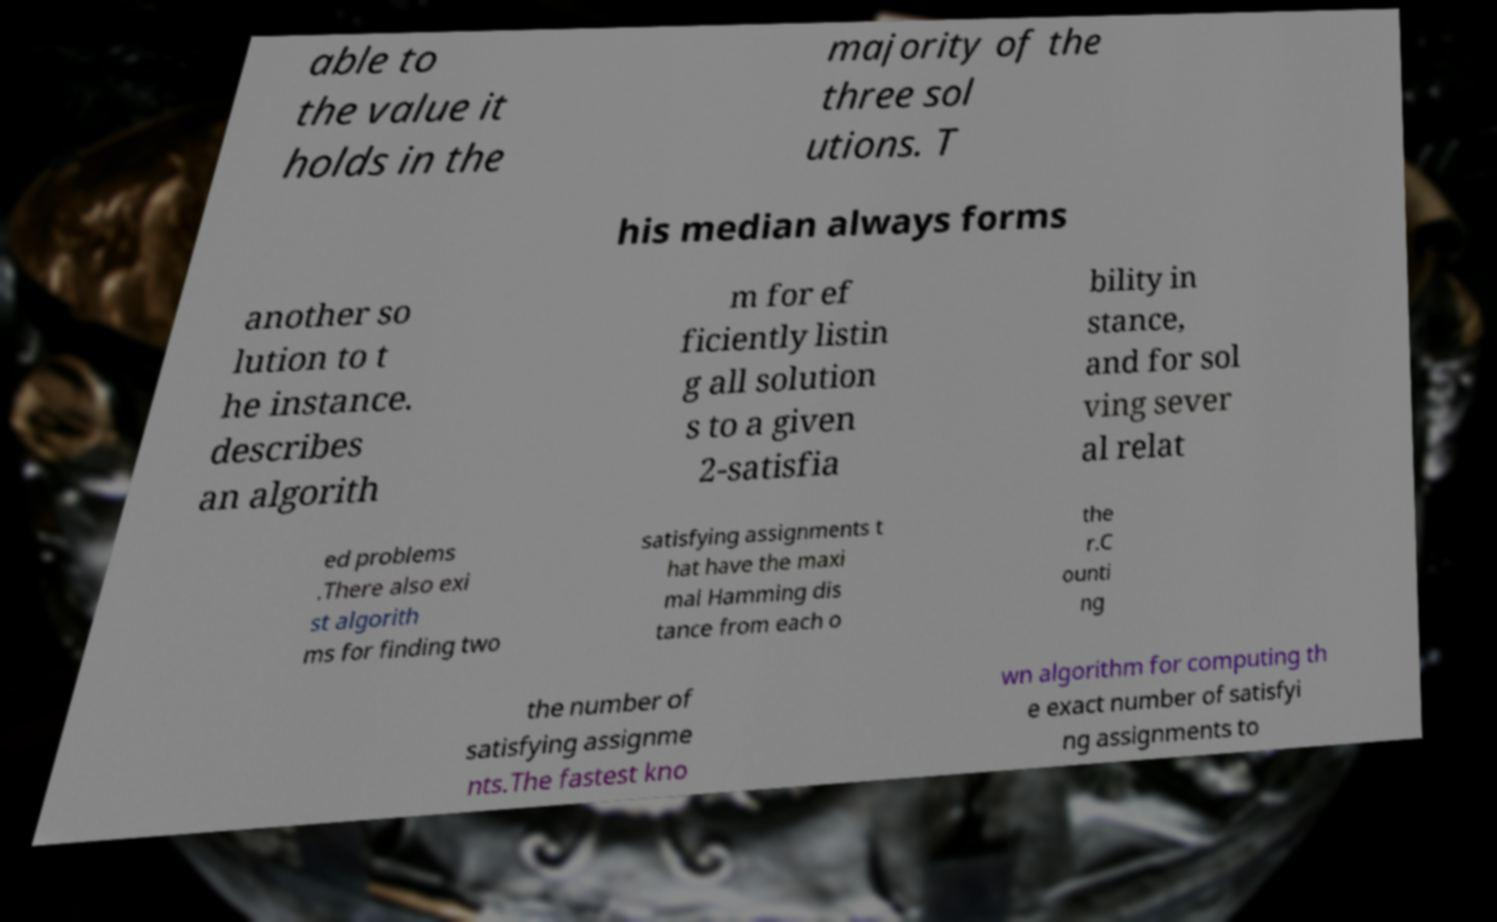Could you assist in decoding the text presented in this image and type it out clearly? able to the value it holds in the majority of the three sol utions. T his median always forms another so lution to t he instance. describes an algorith m for ef ficiently listin g all solution s to a given 2-satisfia bility in stance, and for sol ving sever al relat ed problems .There also exi st algorith ms for finding two satisfying assignments t hat have the maxi mal Hamming dis tance from each o the r.C ounti ng the number of satisfying assignme nts.The fastest kno wn algorithm for computing th e exact number of satisfyi ng assignments to 